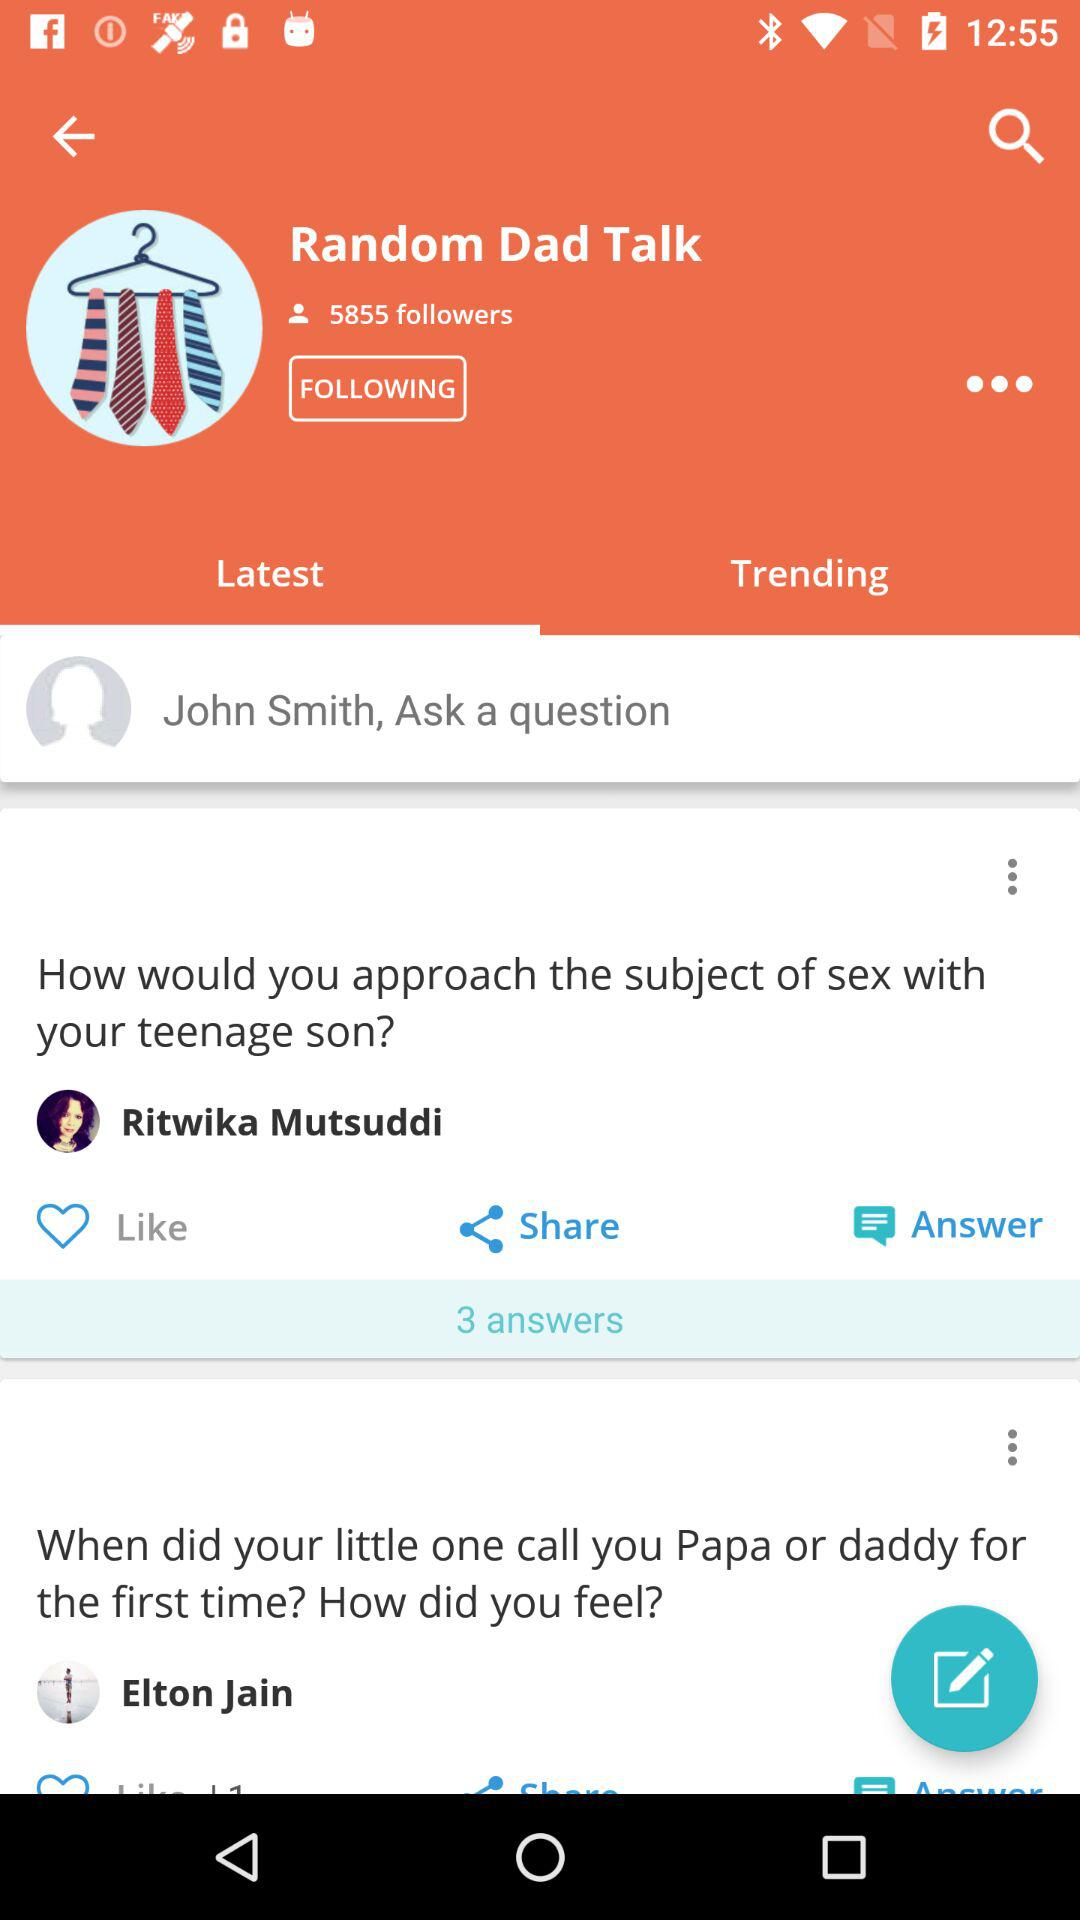How many followers are there? There are 5855 followers. 